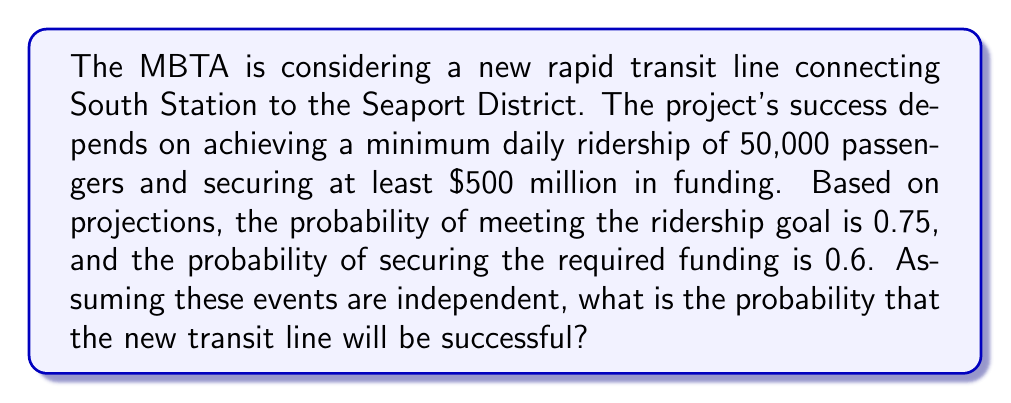Teach me how to tackle this problem. Let's approach this step-by-step:

1) Define events:
   R: Meeting the ridership goal (probability = 0.75)
   F: Securing the required funding (probability = 0.6)

2) The project is successful if both events occur. Since they are independent, we can use the multiplication rule of probability:

   $$P(\text{Success}) = P(R \cap F) = P(R) \cdot P(F)$$

3) Substitute the given probabilities:

   $$P(\text{Success}) = 0.75 \cdot 0.6$$

4) Calculate:

   $$P(\text{Success}) = 0.45$$

5) Convert to percentage:

   $$0.45 \cdot 100\% = 45\%$$

Therefore, the probability that the new transit line will be successful is 45%.
Answer: 45% 